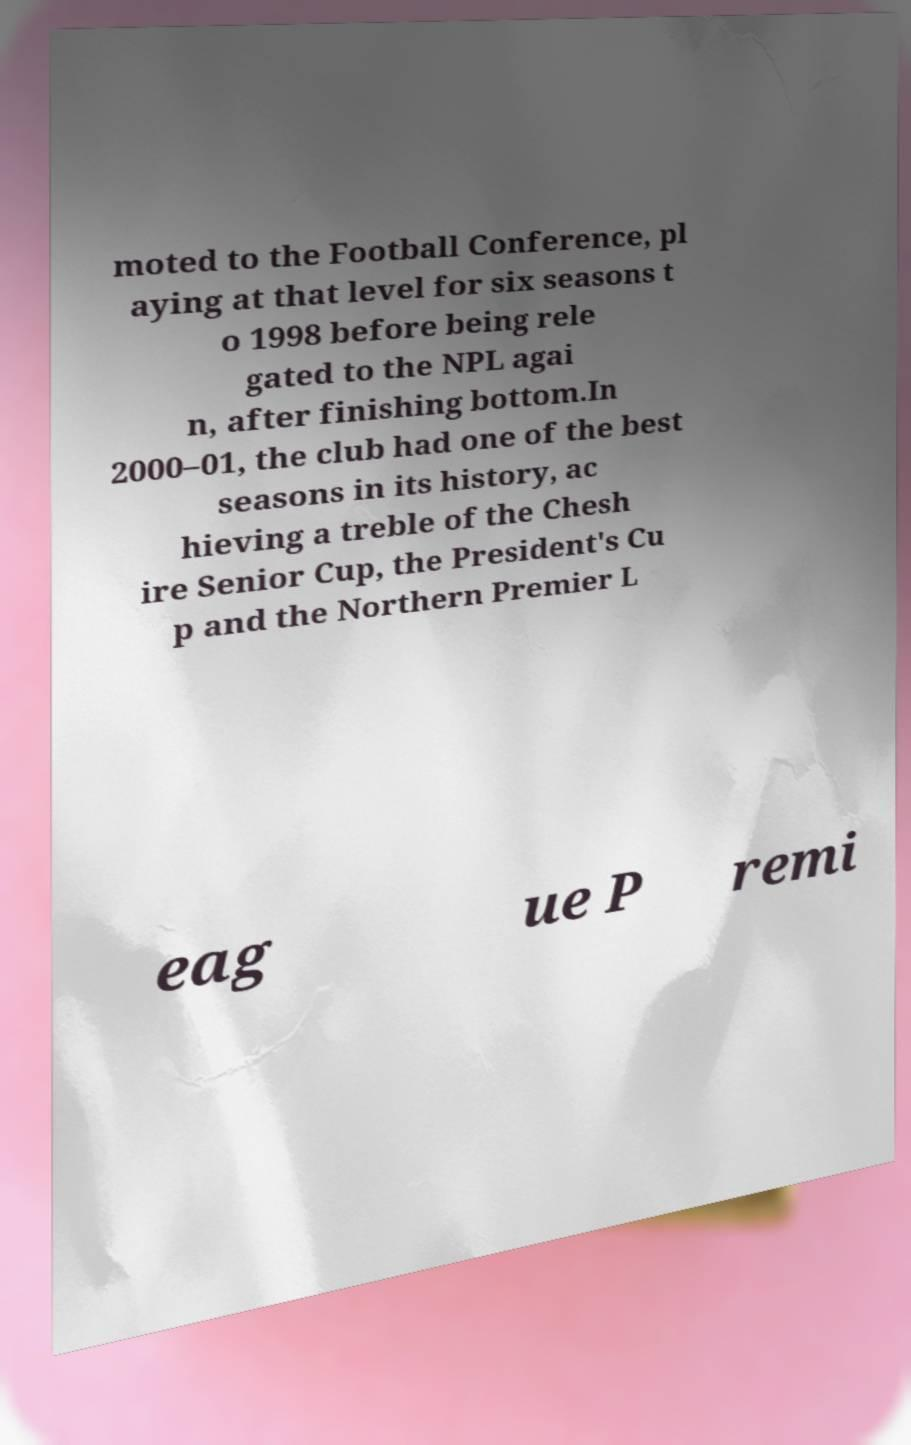Can you read and provide the text displayed in the image?This photo seems to have some interesting text. Can you extract and type it out for me? moted to the Football Conference, pl aying at that level for six seasons t o 1998 before being rele gated to the NPL agai n, after finishing bottom.In 2000–01, the club had one of the best seasons in its history, ac hieving a treble of the Chesh ire Senior Cup, the President's Cu p and the Northern Premier L eag ue P remi 